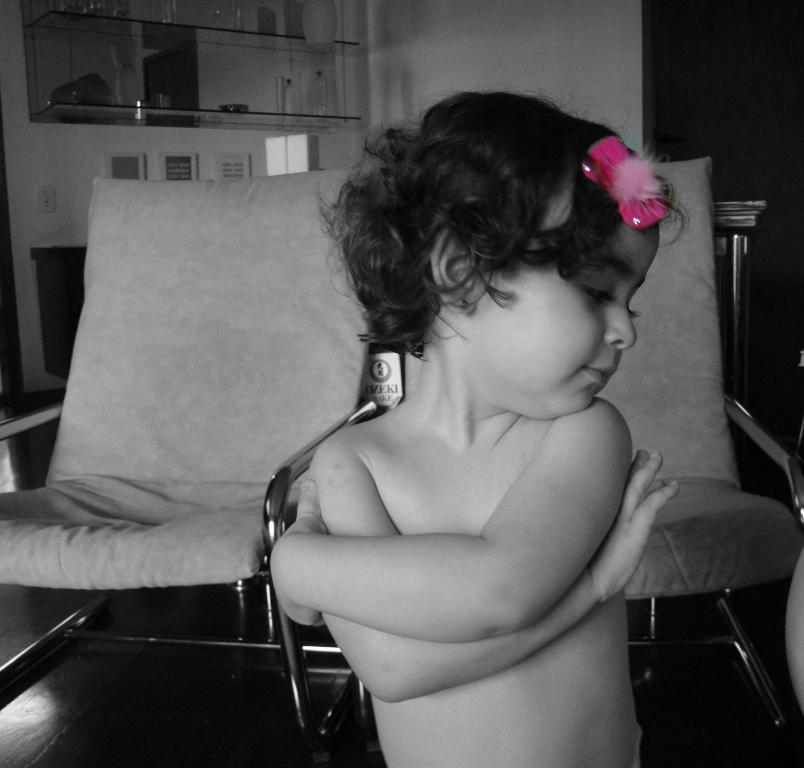What is the color scheme of the image? The image is black and white. Who or what is the main subject in the image? There is a kid in the image. What type of furniture can be seen in the image? There are chairs in the image. What part of the room is visible in the image? The floor is visible in the image. What can be seen in the background of the image? There is a rack and a wall in the background of the image. How many airports are visible in the image? There are no airports present in the image. Can you describe the patch on the kid's clothing in the image? There is no patch mentioned or visible on the kid's clothing in the image. 